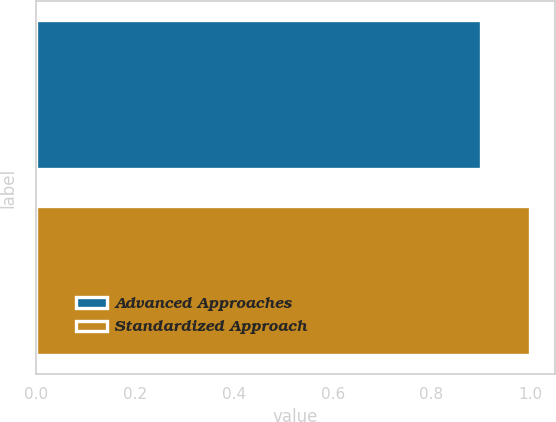<chart> <loc_0><loc_0><loc_500><loc_500><bar_chart><fcel>Advanced Approaches<fcel>Standardized Approach<nl><fcel>0.9<fcel>1<nl></chart> 